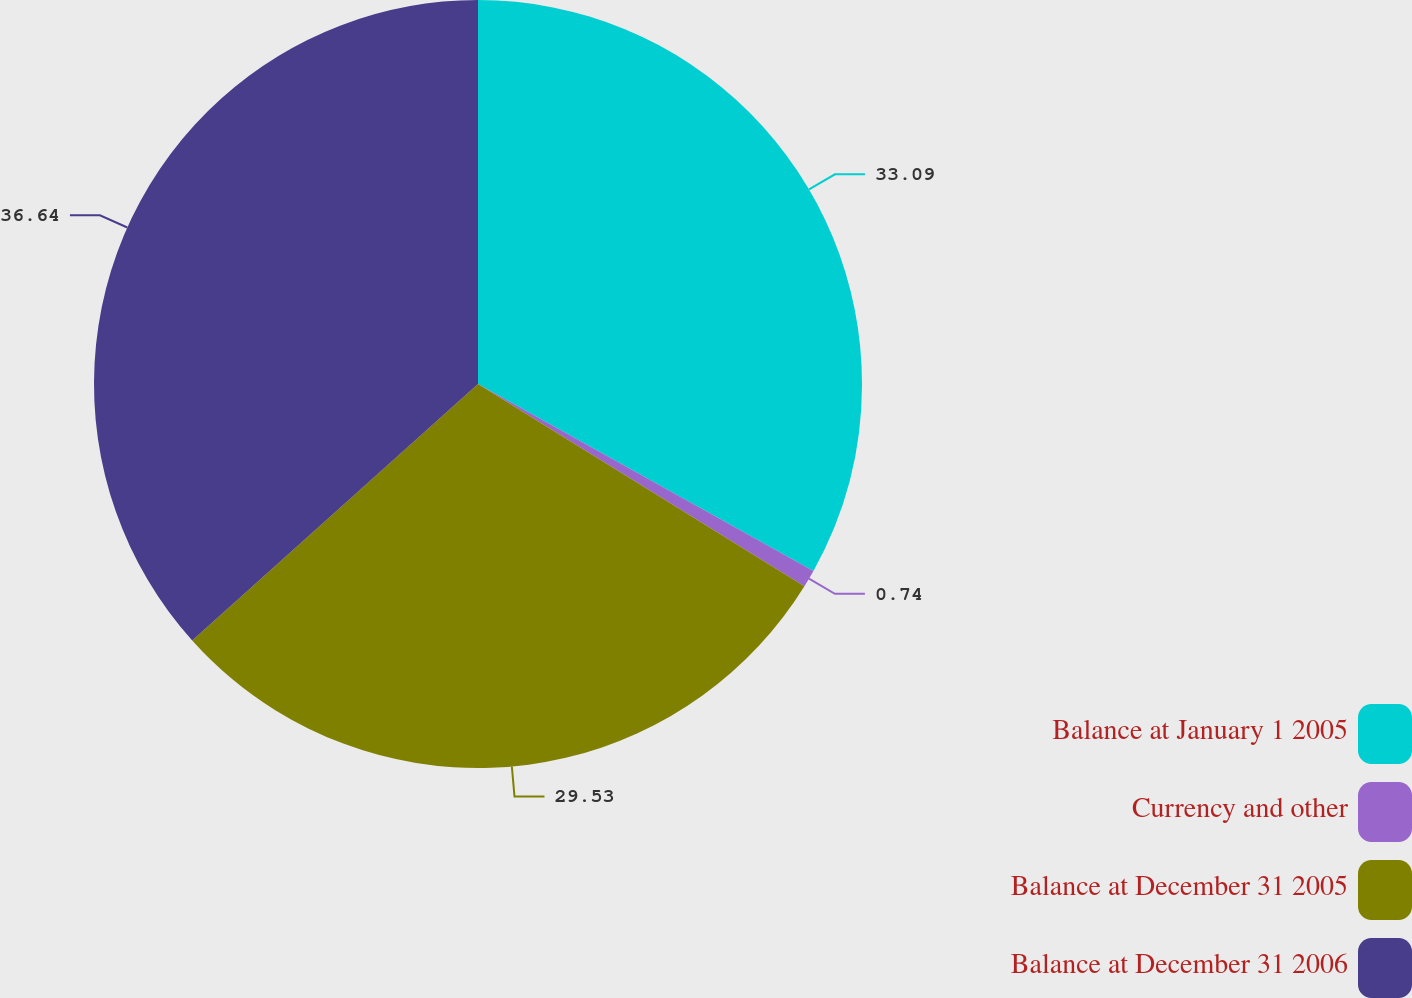Convert chart to OTSL. <chart><loc_0><loc_0><loc_500><loc_500><pie_chart><fcel>Balance at January 1 2005<fcel>Currency and other<fcel>Balance at December 31 2005<fcel>Balance at December 31 2006<nl><fcel>33.09%<fcel>0.74%<fcel>29.53%<fcel>36.64%<nl></chart> 